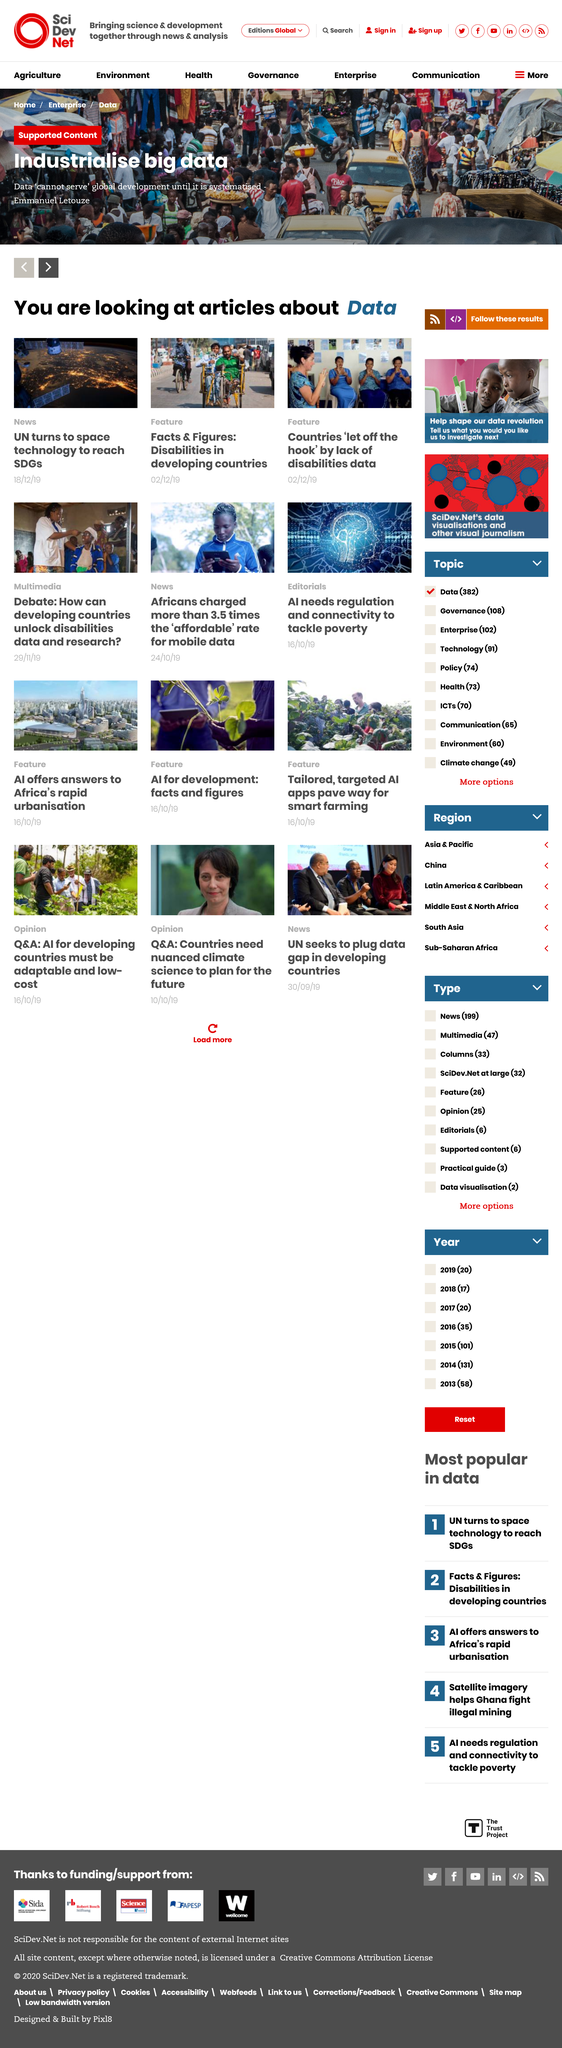Give some essential details in this illustration. The quote is attributed to Emmanuel Letouzé in the top photo. The articles have a common subject, which is data. Based on our analysis, two articles have been classified as Feature articles. 